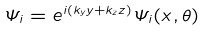<formula> <loc_0><loc_0><loc_500><loc_500>\Psi _ { i } = e ^ { i ( k _ { y } y + k _ { z } z ) } { \Psi _ { i } ( x , \theta ) }</formula> 